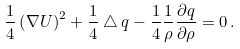Convert formula to latex. <formula><loc_0><loc_0><loc_500><loc_500>\frac { 1 } { 4 } \left ( \nabla U \right ) ^ { 2 } + \frac { 1 } { 4 } \bigtriangleup q - \frac { 1 } { 4 } \frac { 1 } { \rho } \frac { \partial q } { \partial \rho } = 0 \, .</formula> 